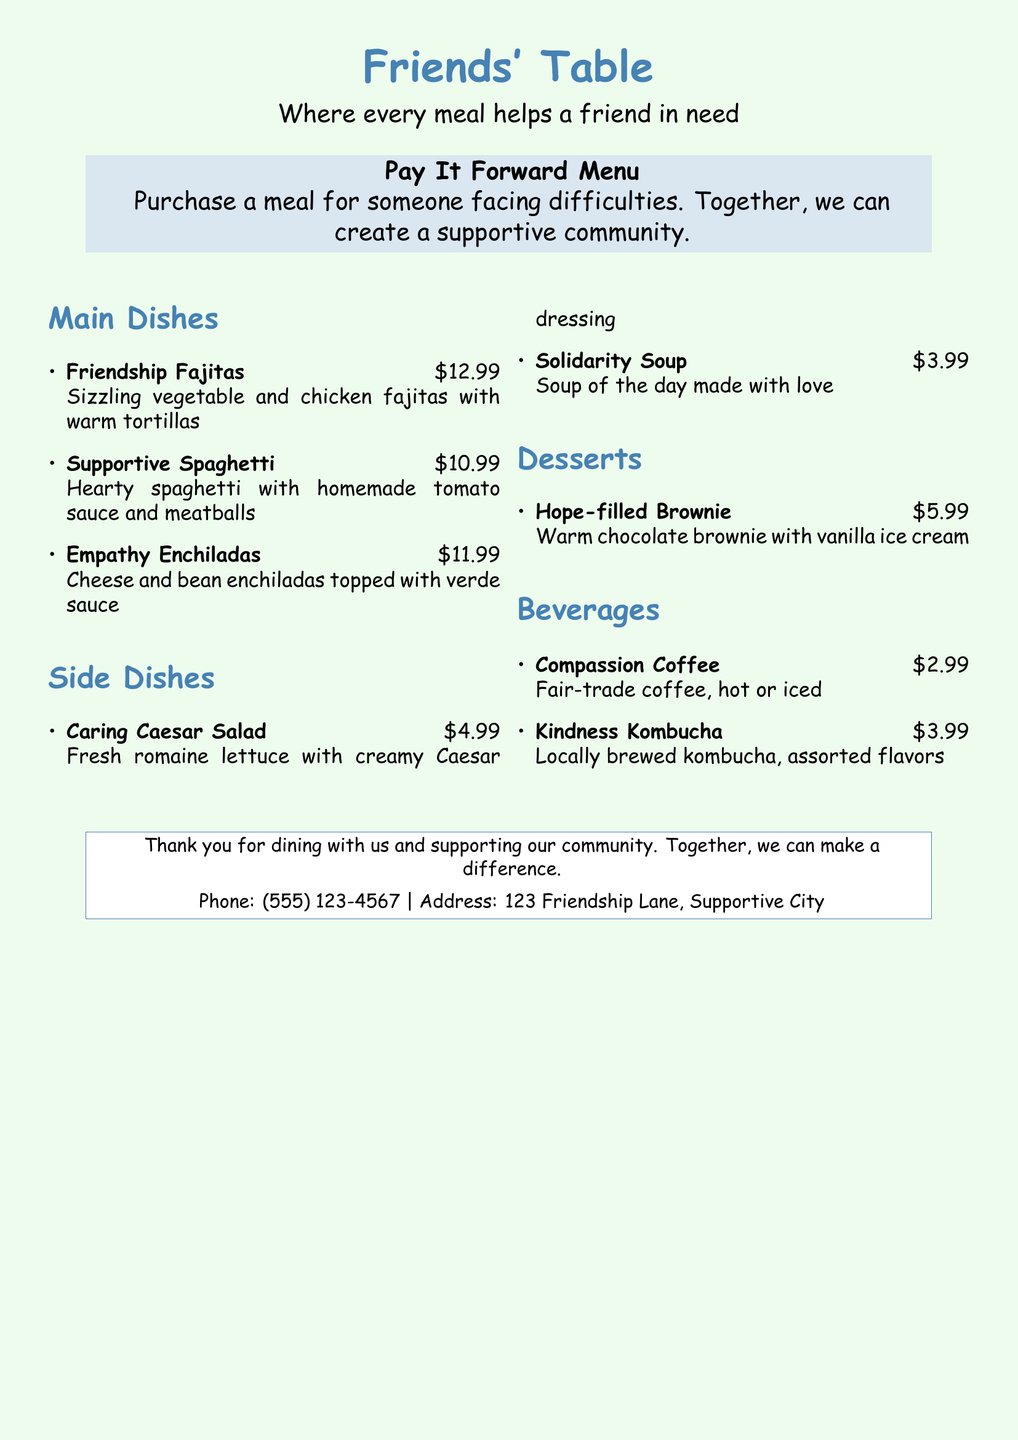What is the name of the first main dish? The first main dish listed in the menu is "Friendship Fajitas."
Answer: Friendship Fajitas What is the price of the "Empathy Enchiladas"? The price listed for the "Empathy Enchiladas" is $11.99.
Answer: $11.99 How much does a bowl of "Solidarity Soup" cost? "Solidarity Soup" is priced at $3.99 according to the menu.
Answer: $3.99 What type of dessert is offered? The menu offers "Hope-filled Brownie" as the dessert.
Answer: Hope-filled Brownie What is the total number of beverages listed? There are two beverages listed in the menu, "Compassion Coffee" and "Kindness Kombucha."
Answer: 2 Which main dish comes with chicken? The main dish that includes chicken is "Friendship Fajitas."
Answer: Friendship Fajitas What is the description of the "Caring Caesar Salad"? The menu describes the "Caring Caesar Salad" as "Fresh romaine lettuce with creamy Caesar dressing."
Answer: Fresh romaine lettuce with creamy Caesar dressing What is the theme of the restaurant? The theme of the restaurant is to support community members in need through meals.
Answer: Supporting community members How can the community benefit from purchasing meals? Purchasing meals contributes to creating a supportive community for those in need.
Answer: Creating a supportive community 